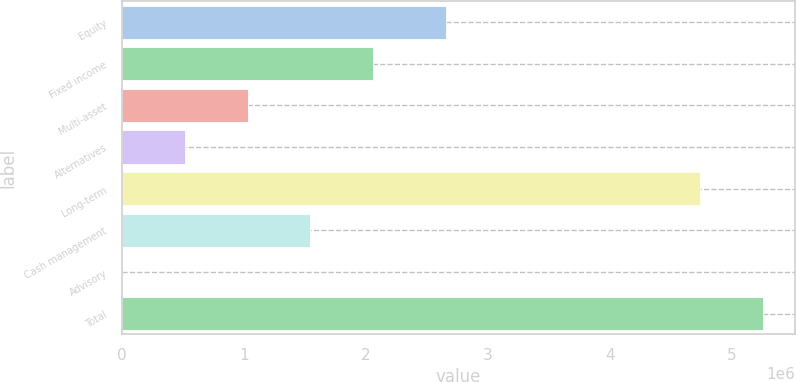Convert chart to OTSL. <chart><loc_0><loc_0><loc_500><loc_500><bar_chart><fcel>Equity<fcel>Fixed income<fcel>Multi-asset<fcel>Alternatives<fcel>Long-term<fcel>Cash management<fcel>Advisory<fcel>Total<nl><fcel>2.65718e+06<fcel>2.06081e+06<fcel>1.0318e+06<fcel>517289<fcel>4.74149e+06<fcel>1.5463e+06<fcel>2782<fcel>5.25599e+06<nl></chart> 